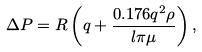Convert formula to latex. <formula><loc_0><loc_0><loc_500><loc_500>\Delta P = R \left ( q + \frac { 0 . 1 7 6 q ^ { 2 } \rho } { l \pi \mu } \right ) ,</formula> 